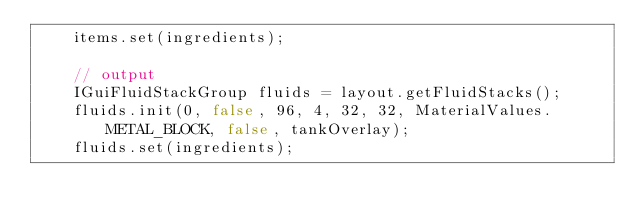<code> <loc_0><loc_0><loc_500><loc_500><_Java_>    items.set(ingredients);

    // output
    IGuiFluidStackGroup fluids = layout.getFluidStacks();
    fluids.init(0, false, 96, 4, 32, 32, MaterialValues.METAL_BLOCK, false, tankOverlay);
    fluids.set(ingredients);
</code> 